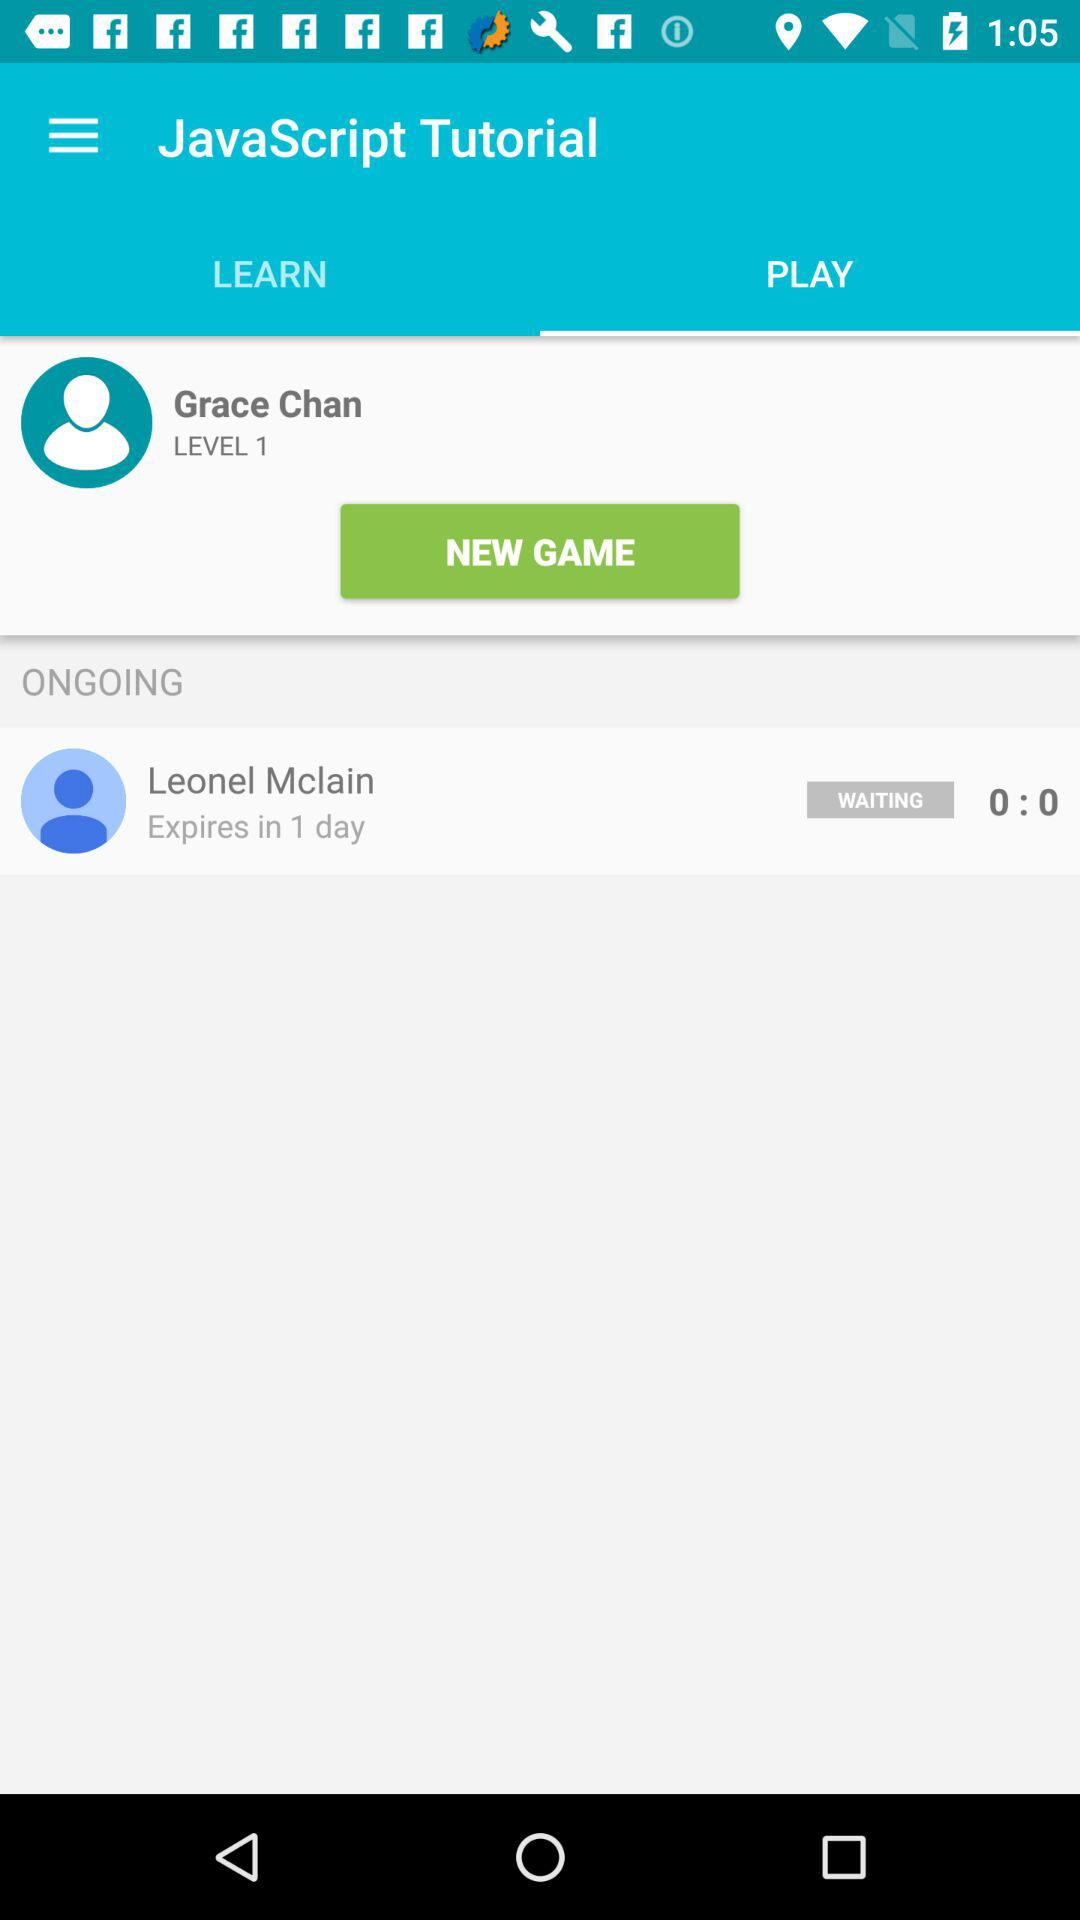What is the level? The level is 1. 